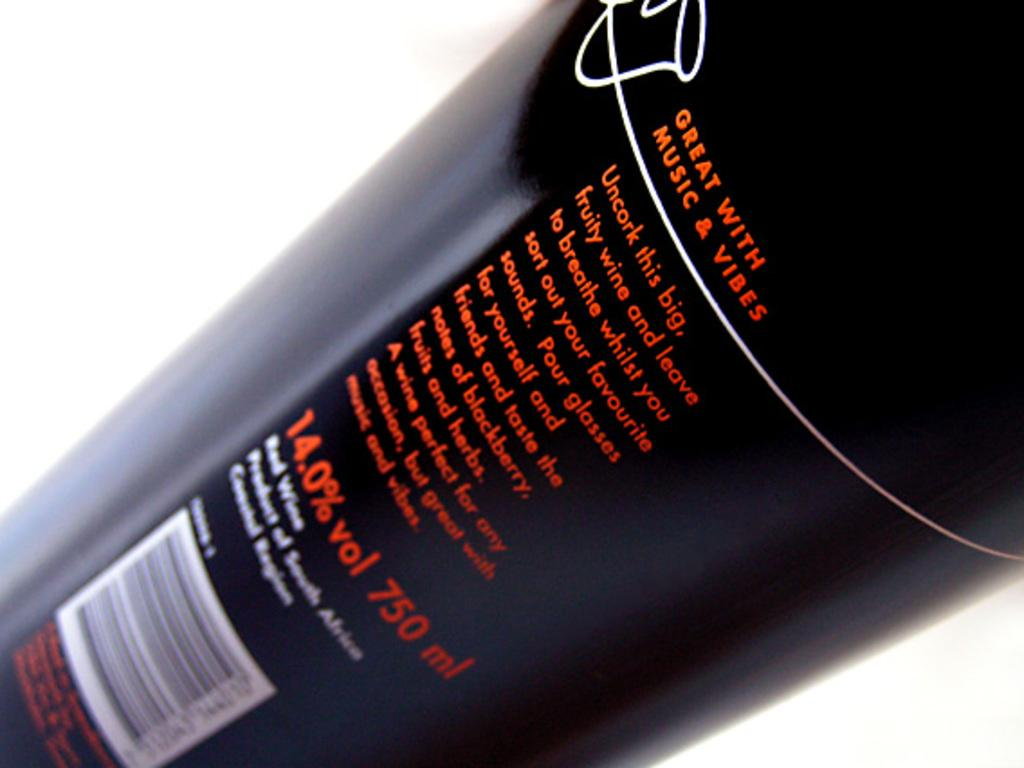<image>
Share a concise interpretation of the image provided. A bottle of fruity wine has 750 milliliters in volume and contains 14 percent alcohol by volume. 